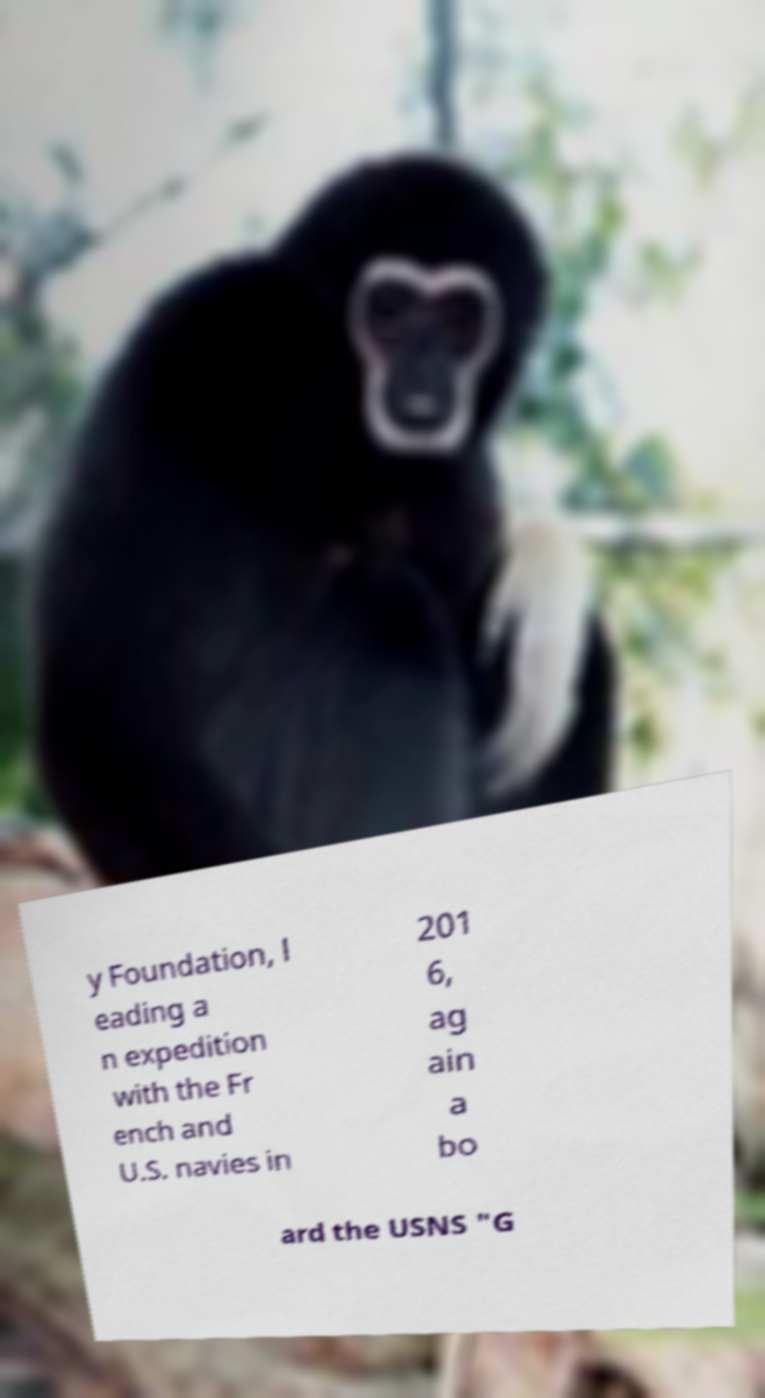Could you assist in decoding the text presented in this image and type it out clearly? y Foundation, l eading a n expedition with the Fr ench and U.S. navies in 201 6, ag ain a bo ard the USNS "G 